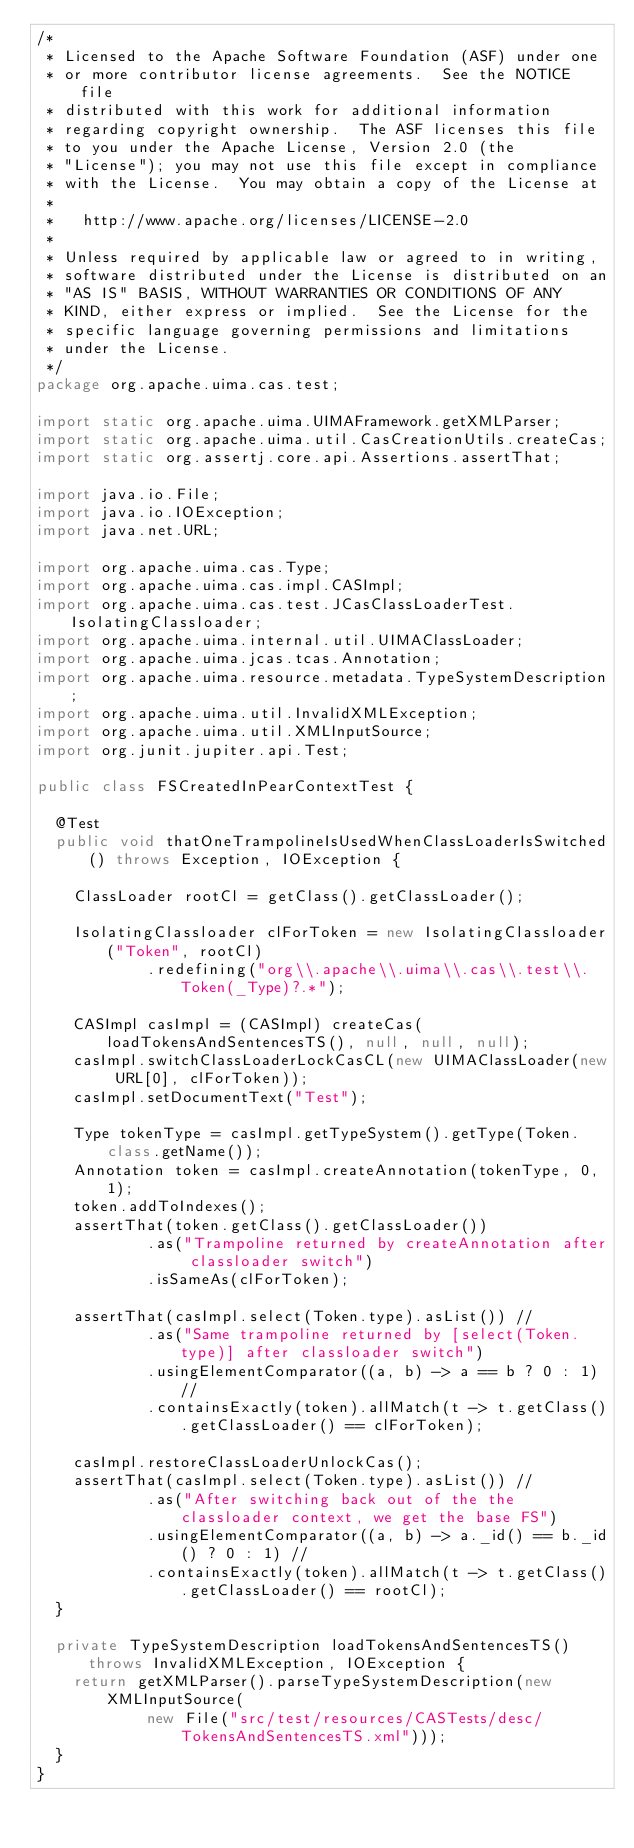Convert code to text. <code><loc_0><loc_0><loc_500><loc_500><_Java_>/*
 * Licensed to the Apache Software Foundation (ASF) under one
 * or more contributor license agreements.  See the NOTICE file
 * distributed with this work for additional information
 * regarding copyright ownership.  The ASF licenses this file
 * to you under the Apache License, Version 2.0 (the
 * "License"); you may not use this file except in compliance
 * with the License.  You may obtain a copy of the License at
 * 
 *   http://www.apache.org/licenses/LICENSE-2.0
 * 
 * Unless required by applicable law or agreed to in writing,
 * software distributed under the License is distributed on an
 * "AS IS" BASIS, WITHOUT WARRANTIES OR CONDITIONS OF ANY
 * KIND, either express or implied.  See the License for the
 * specific language governing permissions and limitations
 * under the License.
 */
package org.apache.uima.cas.test;

import static org.apache.uima.UIMAFramework.getXMLParser;
import static org.apache.uima.util.CasCreationUtils.createCas;
import static org.assertj.core.api.Assertions.assertThat;

import java.io.File;
import java.io.IOException;
import java.net.URL;

import org.apache.uima.cas.Type;
import org.apache.uima.cas.impl.CASImpl;
import org.apache.uima.cas.test.JCasClassLoaderTest.IsolatingClassloader;
import org.apache.uima.internal.util.UIMAClassLoader;
import org.apache.uima.jcas.tcas.Annotation;
import org.apache.uima.resource.metadata.TypeSystemDescription;
import org.apache.uima.util.InvalidXMLException;
import org.apache.uima.util.XMLInputSource;
import org.junit.jupiter.api.Test;

public class FSCreatedInPearContextTest {

  @Test
  public void thatOneTrampolineIsUsedWhenClassLoaderIsSwitched() throws Exception, IOException {

    ClassLoader rootCl = getClass().getClassLoader();

    IsolatingClassloader clForToken = new IsolatingClassloader("Token", rootCl)
            .redefining("org\\.apache\\.uima\\.cas\\.test\\.Token(_Type)?.*");

    CASImpl casImpl = (CASImpl) createCas(loadTokensAndSentencesTS(), null, null, null);
    casImpl.switchClassLoaderLockCasCL(new UIMAClassLoader(new URL[0], clForToken));
    casImpl.setDocumentText("Test");

    Type tokenType = casImpl.getTypeSystem().getType(Token.class.getName());
    Annotation token = casImpl.createAnnotation(tokenType, 0, 1);
    token.addToIndexes();
    assertThat(token.getClass().getClassLoader())
            .as("Trampoline returned by createAnnotation after classloader switch")
            .isSameAs(clForToken);

    assertThat(casImpl.select(Token.type).asList()) //
            .as("Same trampoline returned by [select(Token.type)] after classloader switch")
            .usingElementComparator((a, b) -> a == b ? 0 : 1) //
            .containsExactly(token).allMatch(t -> t.getClass().getClassLoader() == clForToken);

    casImpl.restoreClassLoaderUnlockCas();
    assertThat(casImpl.select(Token.type).asList()) //
            .as("After switching back out of the the classloader context, we get the base FS")
            .usingElementComparator((a, b) -> a._id() == b._id() ? 0 : 1) //
            .containsExactly(token).allMatch(t -> t.getClass().getClassLoader() == rootCl);
  }

  private TypeSystemDescription loadTokensAndSentencesTS() throws InvalidXMLException, IOException {
    return getXMLParser().parseTypeSystemDescription(new XMLInputSource(
            new File("src/test/resources/CASTests/desc/TokensAndSentencesTS.xml")));
  }
}
</code> 